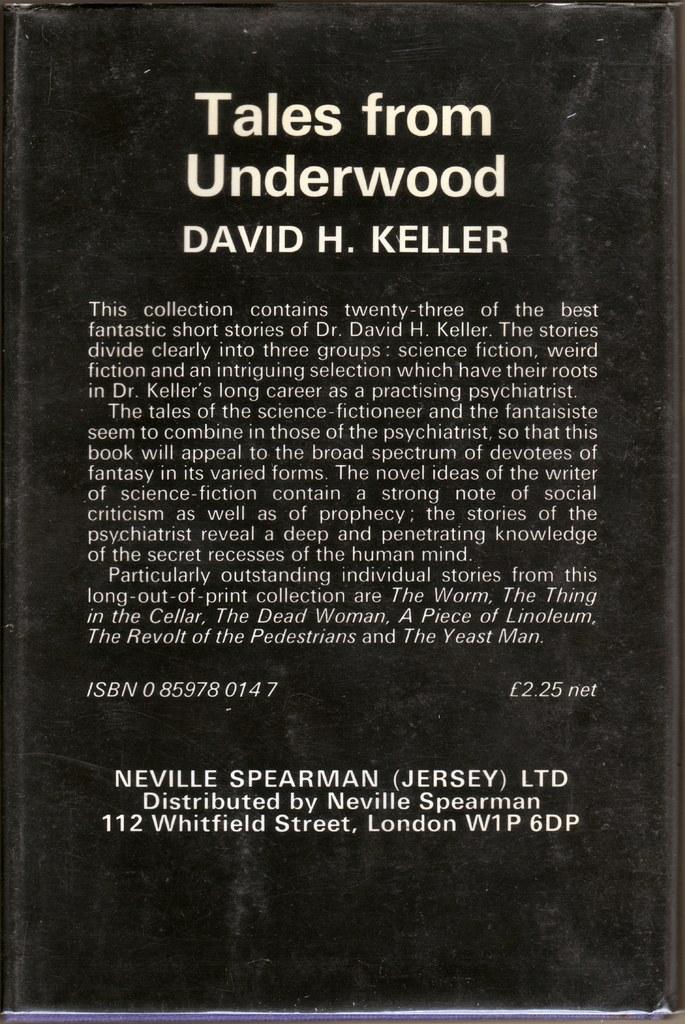Who wrote tales from underwood?
Make the answer very short. David h. keller. What is the title of the book?
Ensure brevity in your answer.  Tales from underwood. 